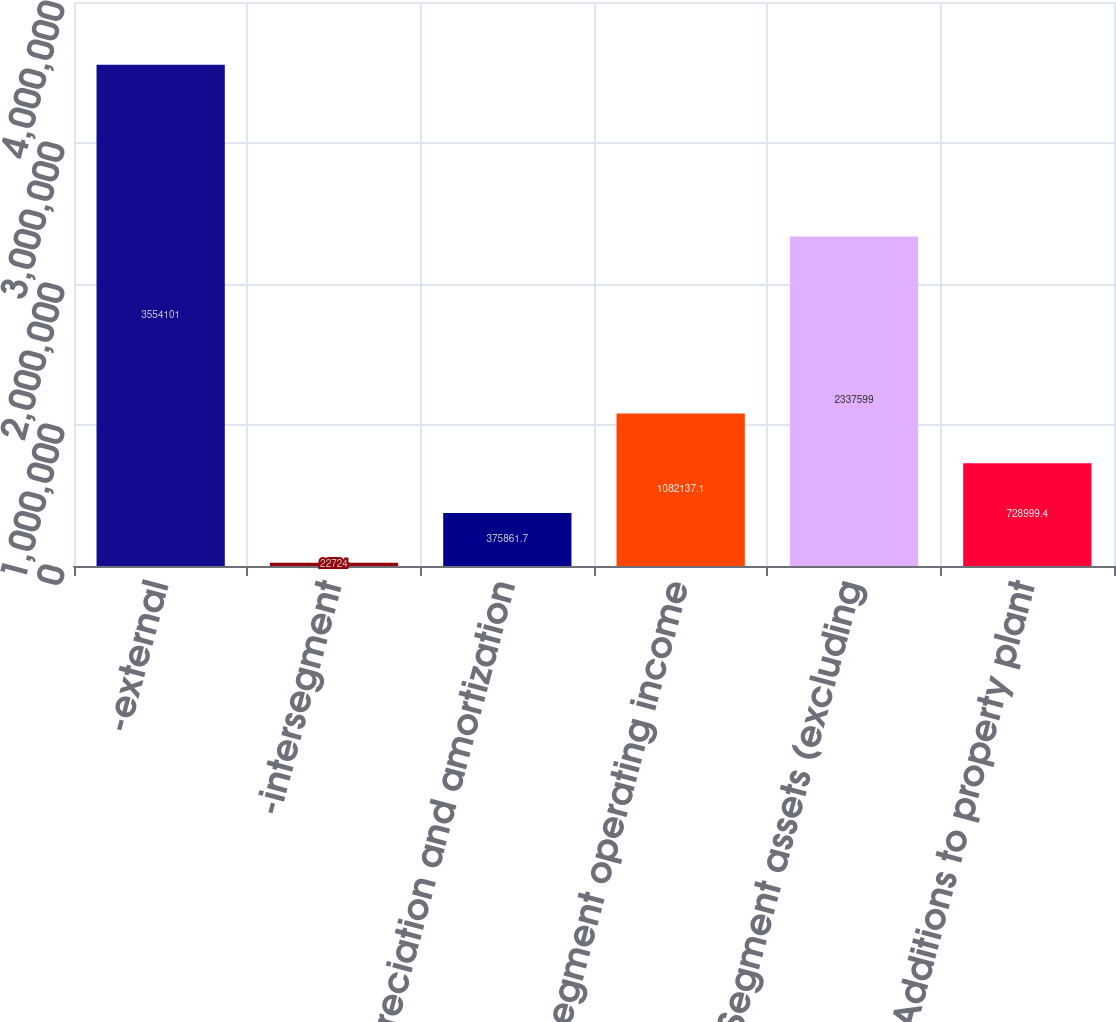Convert chart. <chart><loc_0><loc_0><loc_500><loc_500><bar_chart><fcel>-external<fcel>-intersegment<fcel>Depreciation and amortization<fcel>Segment operating income<fcel>Segment assets (excluding<fcel>Additions to property plant<nl><fcel>3.5541e+06<fcel>22724<fcel>375862<fcel>1.08214e+06<fcel>2.3376e+06<fcel>728999<nl></chart> 